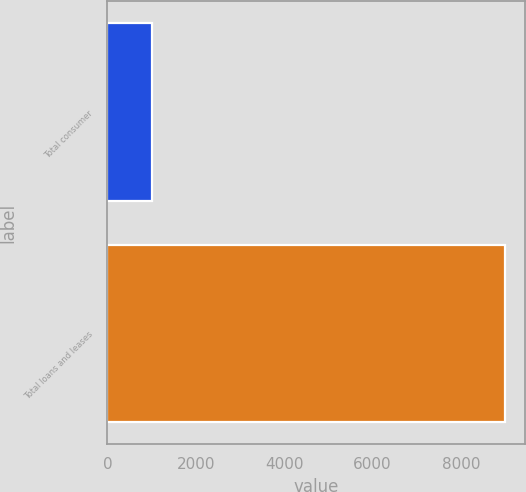Convert chart. <chart><loc_0><loc_0><loc_500><loc_500><bar_chart><fcel>Total consumer<fcel>Total loans and leases<nl><fcel>1005<fcel>9002<nl></chart> 